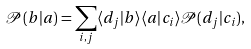Convert formula to latex. <formula><loc_0><loc_0><loc_500><loc_500>\mathcal { P } ( b | a ) = \sum _ { i , j } \langle d _ { j } | b \rangle \langle a | c _ { i } \rangle \mathcal { P } ( d _ { j } | c _ { i } ) ,</formula> 